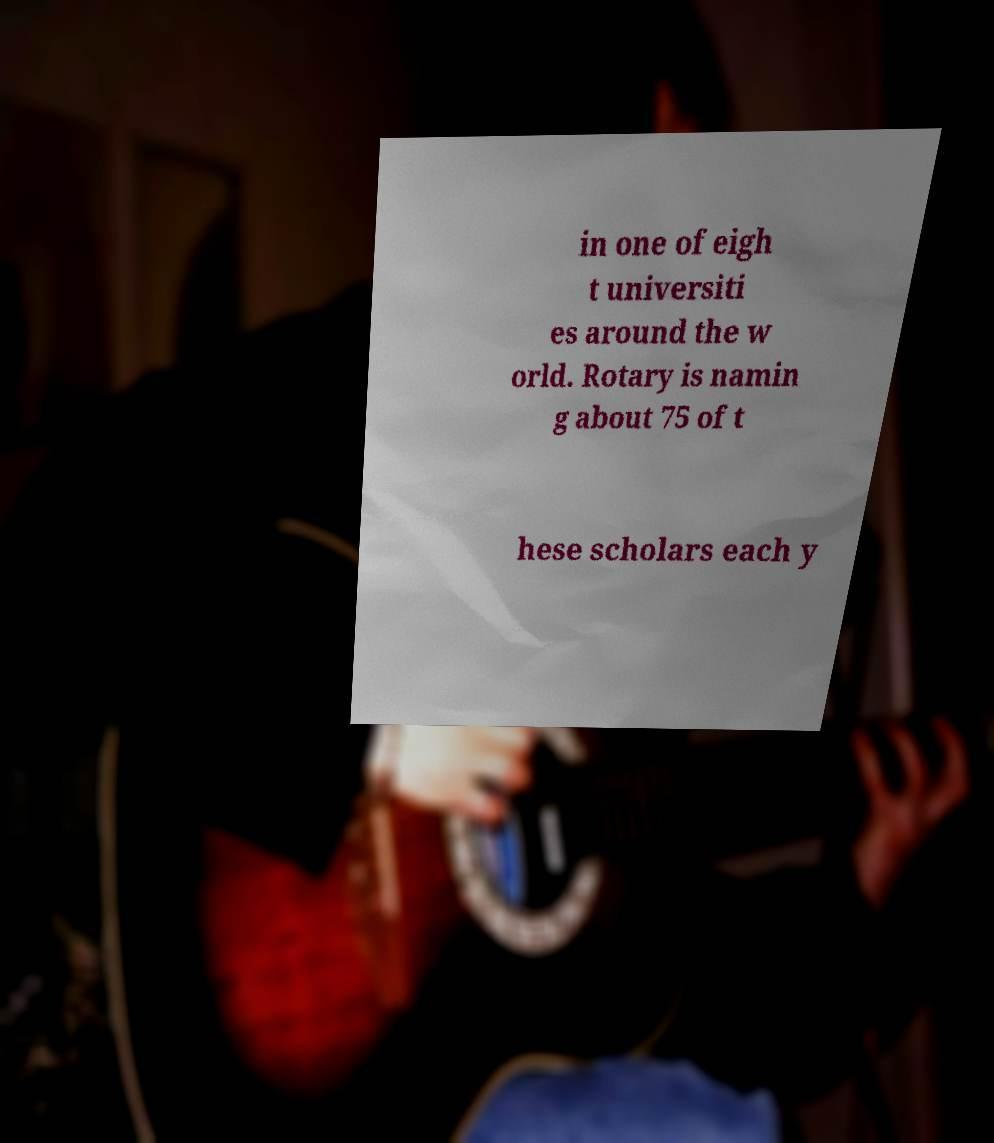Could you assist in decoding the text presented in this image and type it out clearly? in one of eigh t universiti es around the w orld. Rotary is namin g about 75 of t hese scholars each y 